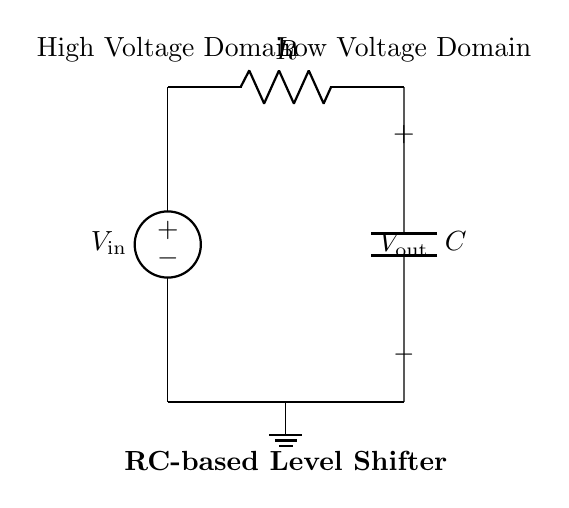What is the input voltage of this circuit? The circuit has a voltage source labeled as \( V_\text{in} \) connected to the input, which indicates the input voltage.
Answer: \( V_\text{in} \) What is the role of the resistor in this circuit? In this RC-based level shifter, the resistor is used to limit the current flowing from the high voltage domain to the capacitor, shaping the voltage transition at the output.
Answer: Current limiting What does the capacitor connect to in this circuit? The capacitor is connected between the output and ground in the low voltage domain, affecting the timing and level shifting behavior.
Answer: Ground What happens to the output voltage when the input voltage goes high? When the input voltage goes high, the capacitor charges through the resistor, and the output voltage will rise toward the high voltage level, but it will be delayed due to the RC time constant.
Answer: It rises What is the function of this RC-based level shifter? This circuit is designed to shift voltage levels between two different voltage domains while providing isolation and protection for components operating at different voltages.
Answer: Voltage level shifting What is the impact of increasing the resistor value in this circuit? Increasing the resistance will reduce the charging current to the capacitor, increasing the RC time constant, which will slow the output voltage transition and can impact signal integrity.
Answer: Slower transitions 